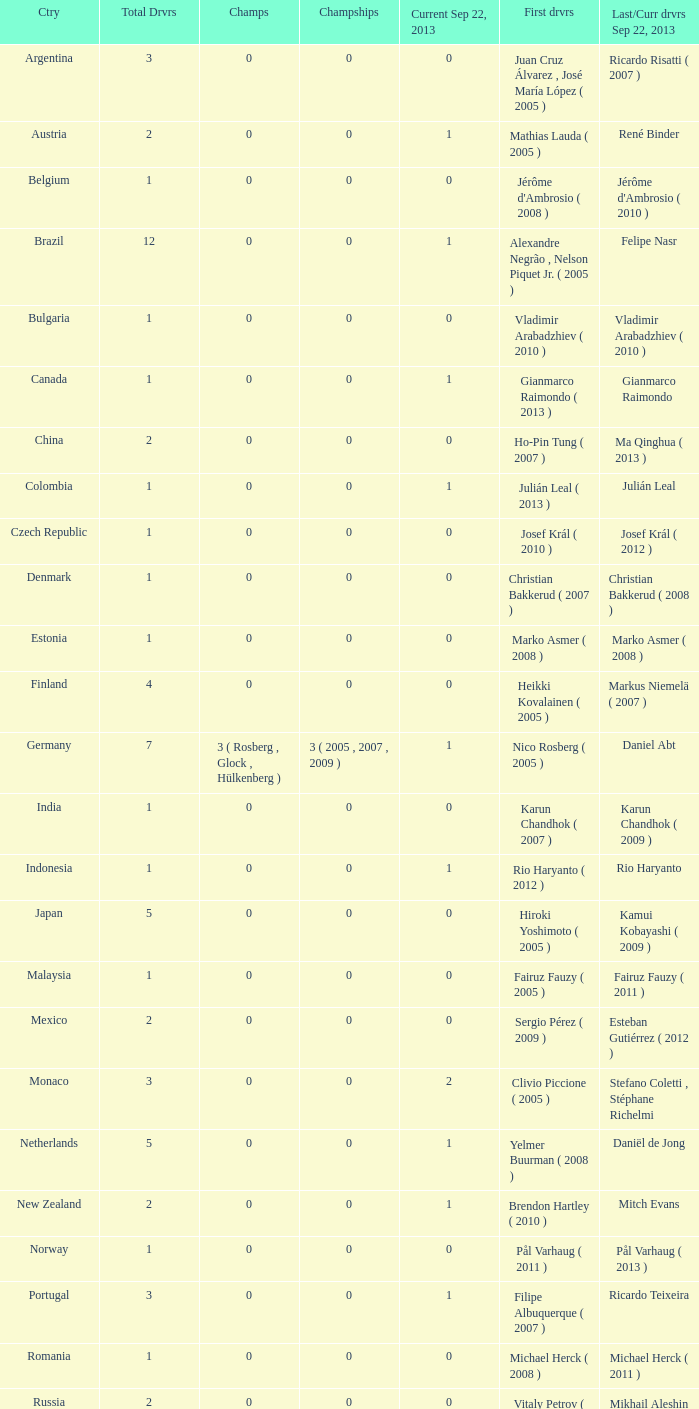How many champions were there when the first driver was hiroki yoshimoto ( 2005 )? 0.0. 